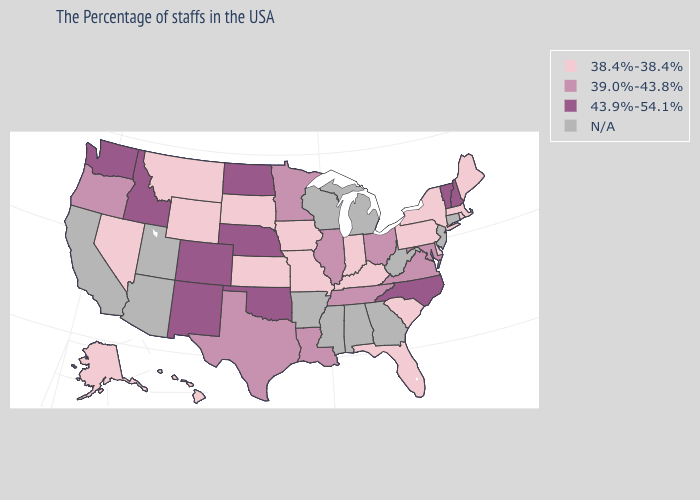Does North Carolina have the lowest value in the USA?
Quick response, please. No. Does the map have missing data?
Quick response, please. Yes. What is the value of Indiana?
Answer briefly. 38.4%-38.4%. What is the lowest value in the USA?
Concise answer only. 38.4%-38.4%. Does Wyoming have the lowest value in the West?
Short answer required. Yes. Which states have the lowest value in the West?
Write a very short answer. Wyoming, Montana, Nevada, Alaska, Hawaii. How many symbols are there in the legend?
Answer briefly. 4. Is the legend a continuous bar?
Concise answer only. No. What is the lowest value in the MidWest?
Be succinct. 38.4%-38.4%. What is the lowest value in the USA?
Concise answer only. 38.4%-38.4%. Name the states that have a value in the range 38.4%-38.4%?
Concise answer only. Maine, Massachusetts, Rhode Island, New York, Delaware, Pennsylvania, South Carolina, Florida, Kentucky, Indiana, Missouri, Iowa, Kansas, South Dakota, Wyoming, Montana, Nevada, Alaska, Hawaii. What is the value of Florida?
Be succinct. 38.4%-38.4%. 